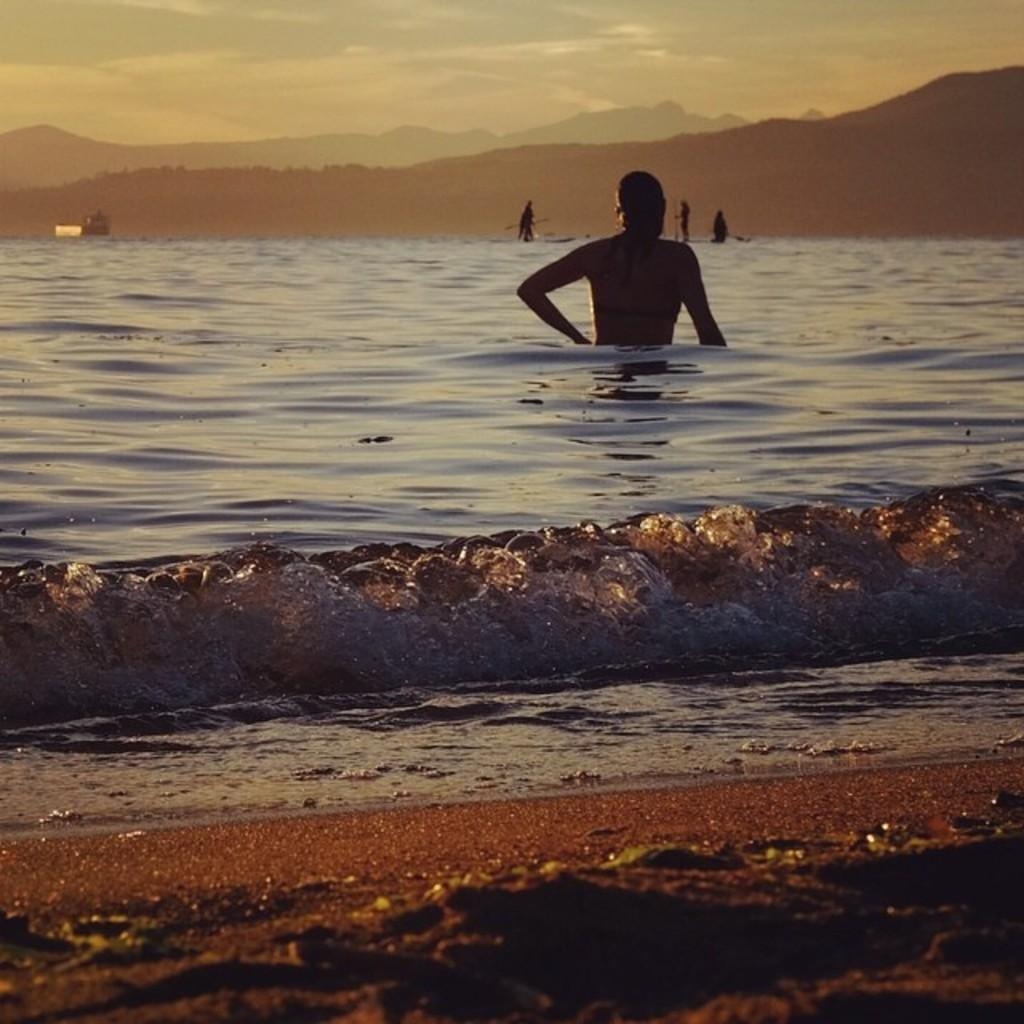What is the person in the image doing? There is a person in the water. Can you describe the background of the image? There are people visible in the background, and there are mountains in the background as well. What is visible in the sky? The sky is visible in the image. What type of vase is being used by the person in the water? There is no vase present in the image; the person is in the water. 